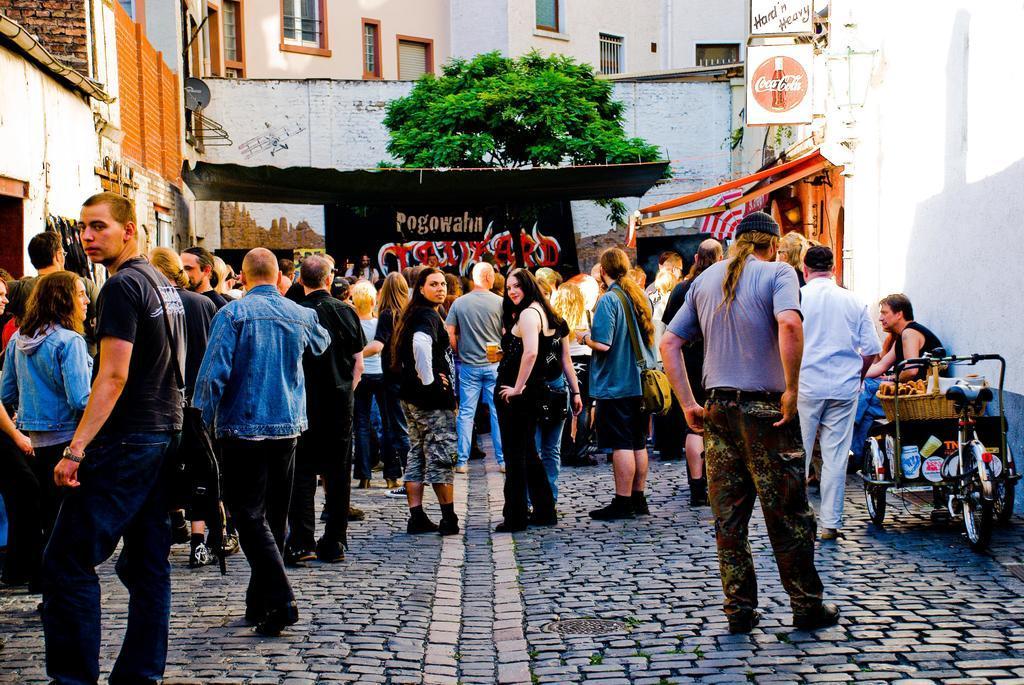Could you give a brief overview of what you see in this image? This picture shows few people standing and a man seated and we see a tree and few buildings and we see a banner and a hoarding. We see a man wore a cap on his head and we see a tricycle on the side. 